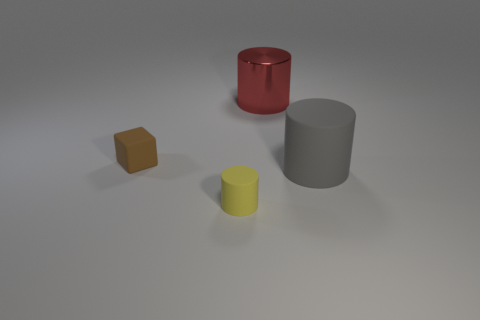What is the color of the cube that is the same size as the yellow object?
Your answer should be compact. Brown. Do the gray cylinder and the yellow rubber object have the same size?
Your answer should be very brief. No. What number of things are right of the yellow cylinder?
Make the answer very short. 2. How many objects are either big objects in front of the matte block or yellow things?
Offer a terse response. 2. Is the number of big objects behind the gray rubber object greater than the number of yellow rubber things to the right of the tiny yellow thing?
Give a very brief answer. Yes. Is the size of the yellow cylinder the same as the rubber thing to the left of the yellow matte object?
Offer a very short reply. Yes. How many blocks are either brown things or small yellow things?
Offer a terse response. 1. There is a brown block that is made of the same material as the gray object; what size is it?
Provide a short and direct response. Small. Does the gray thing that is right of the block have the same size as the yellow rubber cylinder that is in front of the large red metallic object?
Your answer should be compact. No. How many objects are tiny gray metallic cubes or shiny cylinders?
Give a very brief answer. 1. 